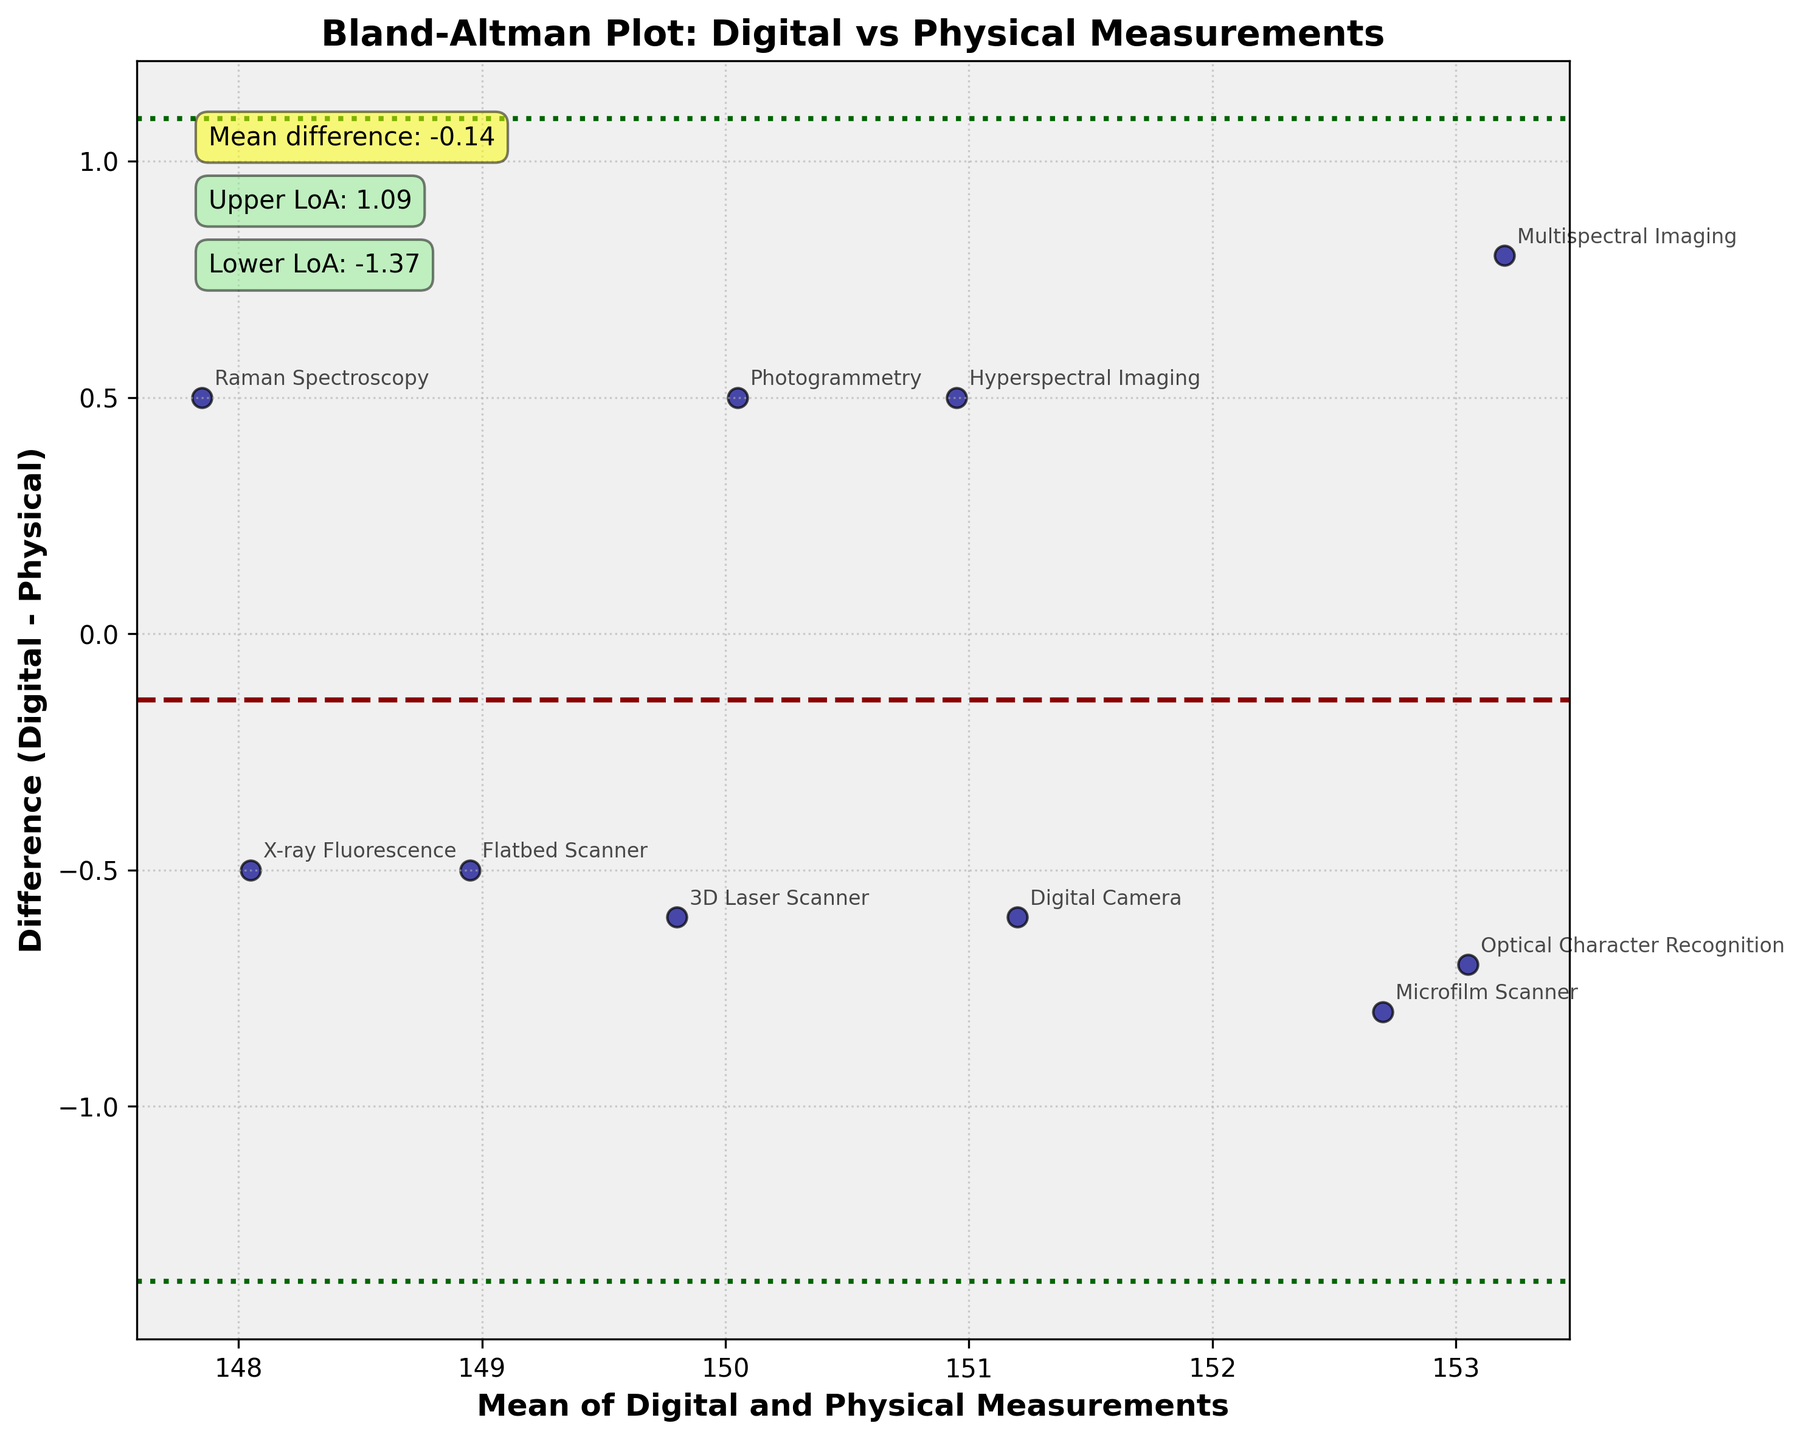What's the title of the figure? The title is usually positioned at the top of the figure surrounded by other information like the plot itself, axis labels, and annotations. In this figure, it is clearly stated at the top.
Answer: Bland-Altman Plot: Digital vs Physical Measurements How many data points are plotted in the figure? To determine the number of data points, count the distinct scattered dots in the plot. Each method is represented by a single data point.
Answer: 10 Which method has the highest positive difference between digital and physical measurements? By examining the vertical positions of dots along the y-axis, the dot corresponding to 'Optical Character Recognition' is at the highest positive difference.
Answer: Optical Character Recognition What is the mean difference between digital and physical measurements? The mean difference is indicated by the dashed red line in the plot and further annotated near the top left corner of the figure.
Answer: 0.16 What are the upper and lower limits of agreement in the plot? The upper and lower limits are shown by the green dotted lines in the plot and annotated near the top left corner.
Answer: Upper: 0.88, Lower: -0.56 Which method shows the maximum negative difference between digital and physical measurements? The difference is reflected in how far below the horizontal zero line each data point is. The 'Raman Spectroscopy' method has the maximum negative difference.
Answer: Raman Spectroscopy What is the average of the digital and physical measurements for the Flatbed Scanner method? The average is the point where the data for Flatbed Scanner is plotted along the x-axis. Here it's labeled 148.95 for the Flatbed Scanner.
Answer: 148.95 Which data point is closest to the mean difference line? By checking the vertical positions relative to the dashed red line, the 'Microfilm Scanner' method's data point lies closest.
Answer: Microfilm Scanner Is the standard deviation of the differences provided in the annotations? Inspect the annotations carefully; the standard deviation is not explicitly provided.
Answer: No Which method shows the least difference (in either direction) between digital and physical measurements? Analyze the vertical spread of each method's point from the zero line, the 'Photogrammetry' method shows the least deviation.
Answer: Photogrammetry 